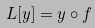Convert formula to latex. <formula><loc_0><loc_0><loc_500><loc_500>L [ y ] = y \circ f</formula> 